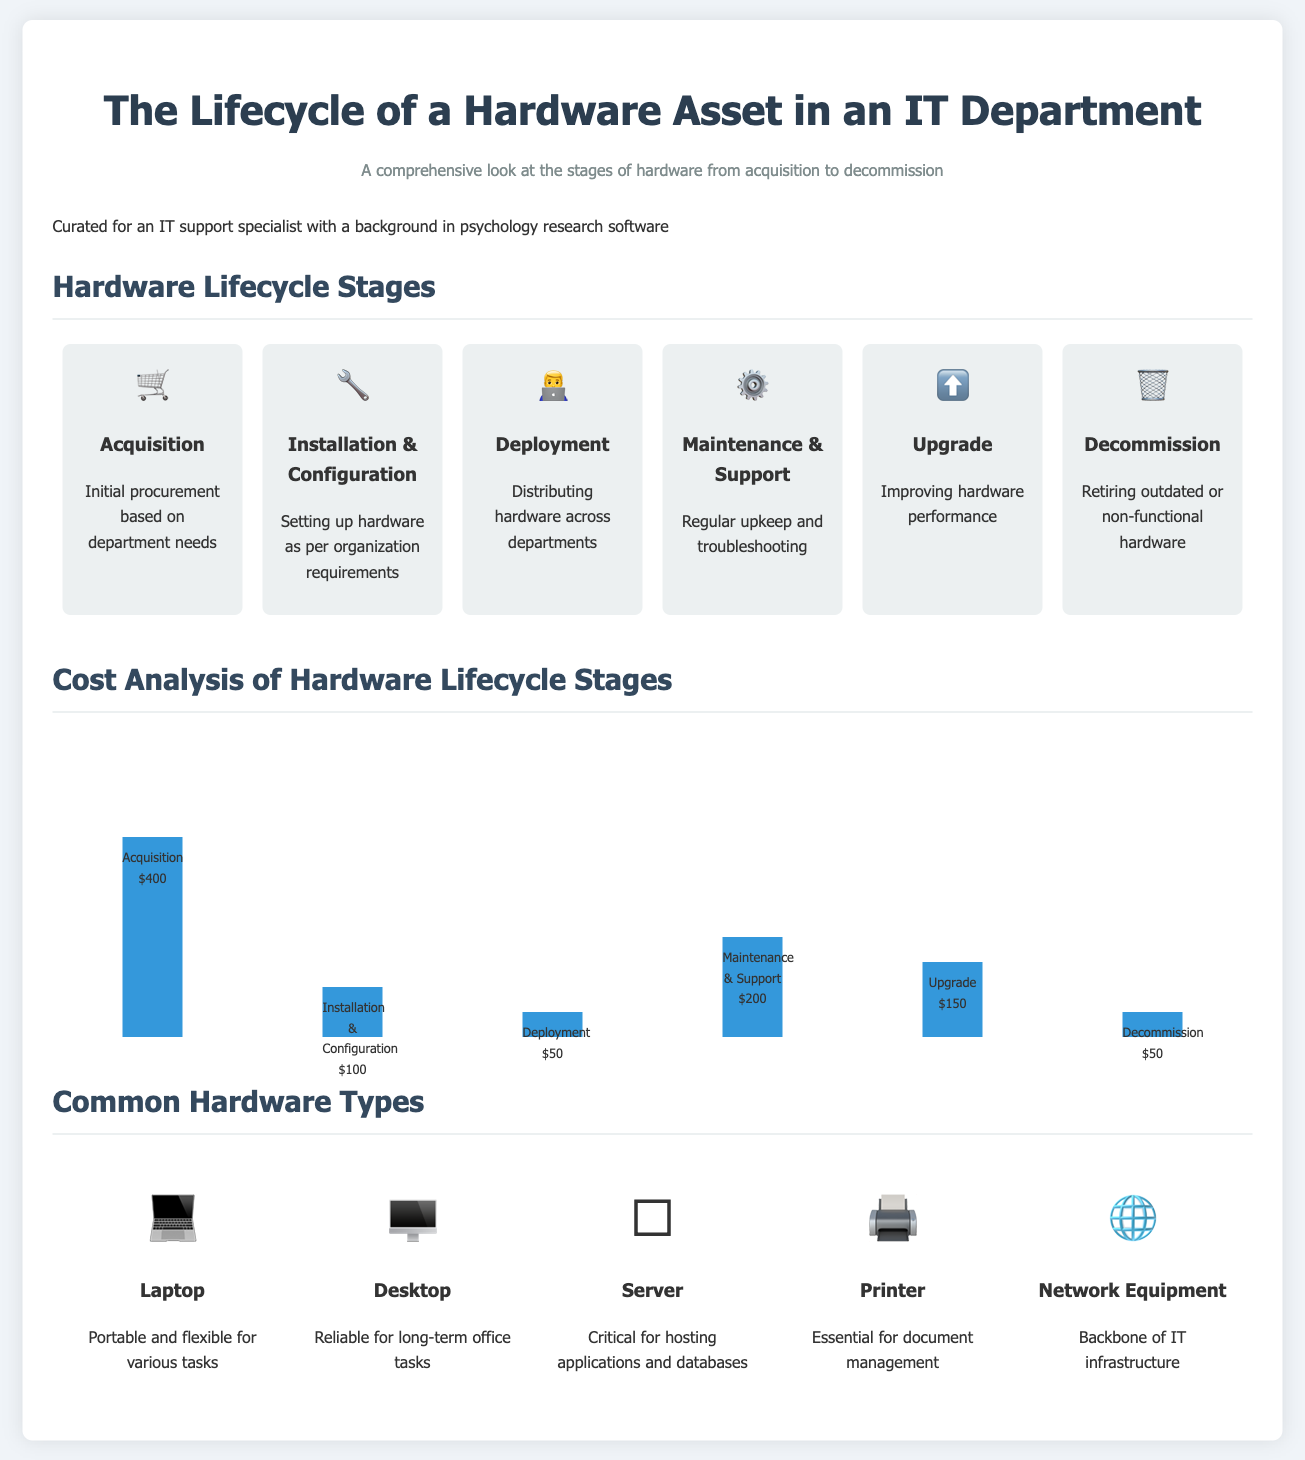What is the initial procurement stage called? The document identifies the first stage of the hardware asset lifecycle as "Acquisition."
Answer: Acquisition What is the cost of Maintenance & Support? The bar graph shows that Maintenance & Support costs $200.
Answer: $200 Which icon represents the Decommission stage? The document features a trash can emoji for the Decommission stage.
Answer: 🗑️ How many stages are there in the hardware lifecycle? The document outlines a total of six stages in the hardware asset lifecycle.
Answer: 6 What hardware type is described as critical for hosting applications? The server is indicated as essential for hosting applications and databases.
Answer: Server What is the cost of installing and configuring hardware? According to the cost analysis, Installation & Configuration costs $100.
Answer: $100 Which hardware type is seen as portable? The infographics label laptops as portable and flexible for various tasks.
Answer: Laptop What does the upgrade stage aim to improve? The document states that the Upgrade stage focuses on improving hardware performance.
Answer: Performance What is the purpose of the document? The document aims to provide a comprehensive look at the stages of hardware from acquisition to decommission.
Answer: Comprehensive look 